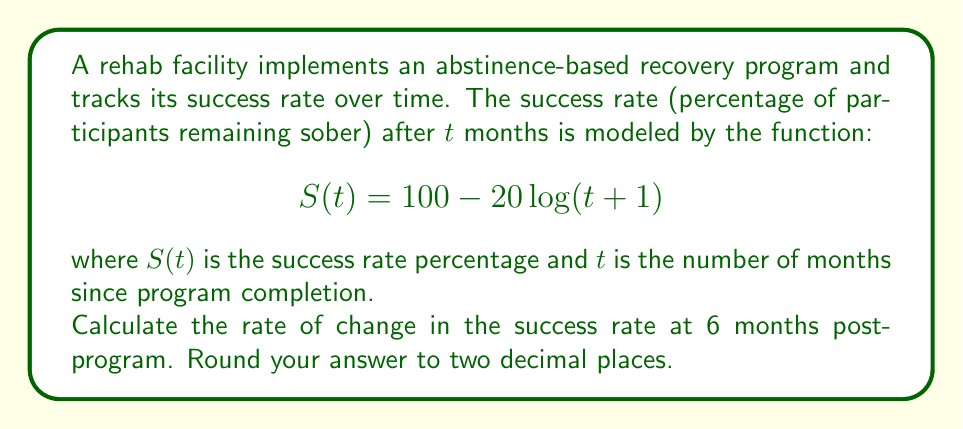Could you help me with this problem? To find the rate of change in the success rate at 6 months, we need to calculate the derivative of the function $S(t)$ and evaluate it at $t=6$.

Step 1: Find the derivative of $S(t)$.
$$S(t) = 100 - 20\log(t+1)$$
$$\frac{d}{dt}S(t) = -20 \cdot \frac{d}{dt}\log(t+1)$$
$$\frac{d}{dt}S(t) = -20 \cdot \frac{1}{t+1}$$

Step 2: Evaluate the derivative at $t=6$.
$$\frac{d}{dt}S(6) = -20 \cdot \frac{1}{6+1} = -20 \cdot \frac{1}{7}$$

Step 3: Calculate the result.
$$\frac{d}{dt}S(6) = -\frac{20}{7} \approx -2.8571$$

Step 4: Round to two decimal places.
$$\frac{d}{dt}S(6) \approx -2.86$$

The negative value indicates that the success rate is decreasing at 6 months post-program.
Answer: -2.86 percentage points per month 